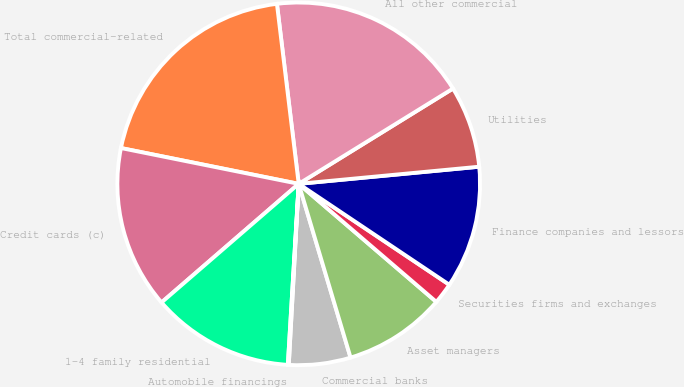Convert chart. <chart><loc_0><loc_0><loc_500><loc_500><pie_chart><fcel>Commercial banks<fcel>Asset managers<fcel>Securities firms and exchanges<fcel>Finance companies and lessors<fcel>Utilities<fcel>All other commercial<fcel>Total commercial-related<fcel>Credit cards (c)<fcel>1-4 family residential<fcel>Automobile financings<nl><fcel>5.49%<fcel>9.1%<fcel>1.89%<fcel>10.9%<fcel>7.3%<fcel>18.11%<fcel>19.92%<fcel>14.51%<fcel>12.7%<fcel>0.08%<nl></chart> 